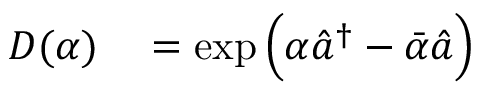Convert formula to latex. <formula><loc_0><loc_0><loc_500><loc_500>\begin{array} { r l } { D ( \alpha ) } & = \exp \left ( \alpha \hat { a } ^ { \dagger } - \bar { \alpha } \hat { a } \right ) } \end{array}</formula> 